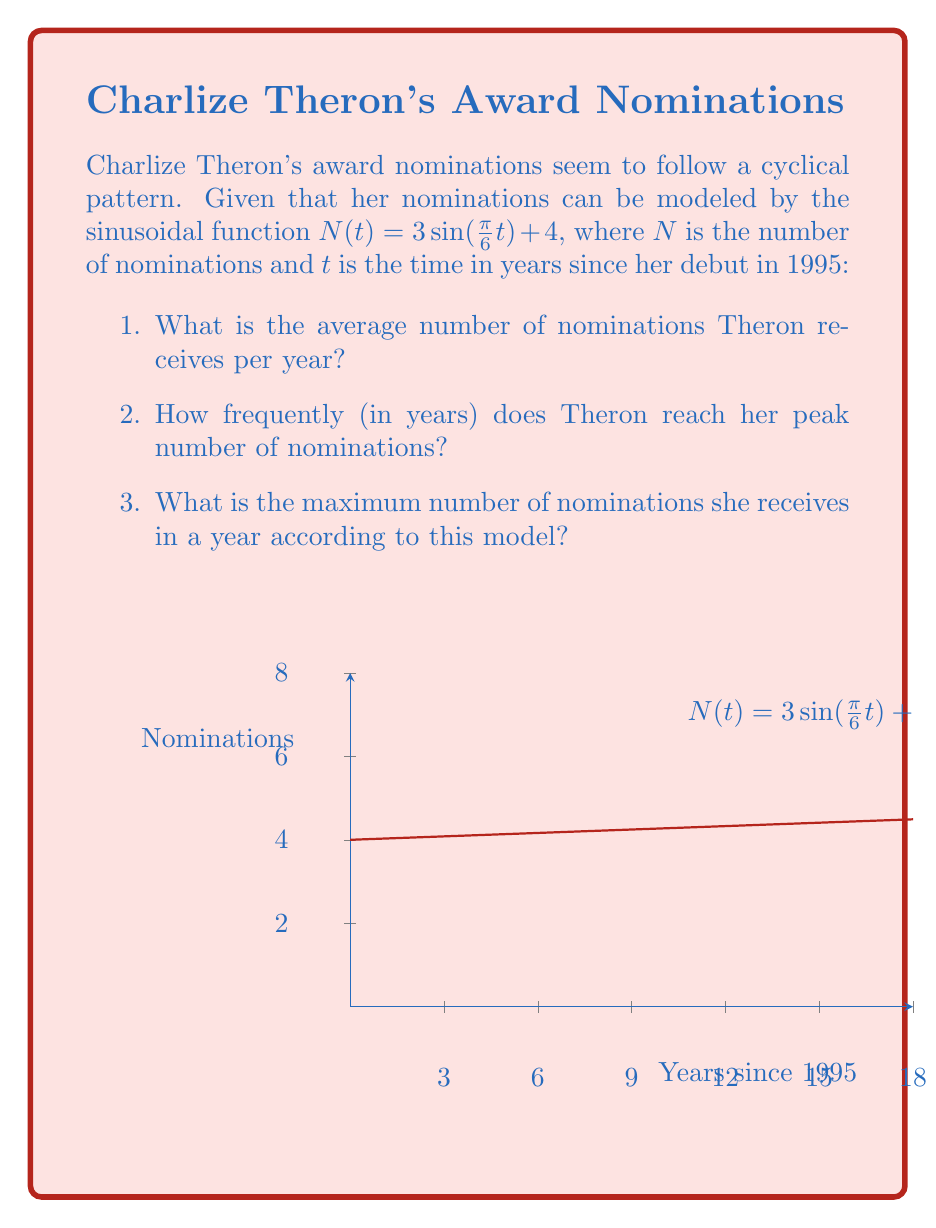Provide a solution to this math problem. Let's break this down step-by-step:

1. The average number of nominations:
   The function oscillates around the midline of the sine wave. This midline is represented by the constant term in the equation. Here, it's 4.

2. Frequency of peak nominations:
   The period of a sine function is given by $\frac{2\pi}{B}$, where $B$ is the coefficient of $t$ inside the sine function.
   In this case, $B = \frac{\pi}{6}$
   So, the period = $\frac{2\pi}{\frac{\pi}{6}} = 12$ years

3. Maximum number of nominations:
   The amplitude of the sine wave is 3 (the coefficient of the sine term).
   The maximum occurs when this amplitude is added to the midline.
   Maximum = Midline + Amplitude = 4 + 3 = 7

Therefore:
1. On average, Theron receives 4 nominations per year.
2. She reaches her peak number of nominations every 12 years.
3. The maximum number of nominations she receives in a year is 7.
Answer: 1. 4 nominations/year
2. 12 years
3. 7 nominations 